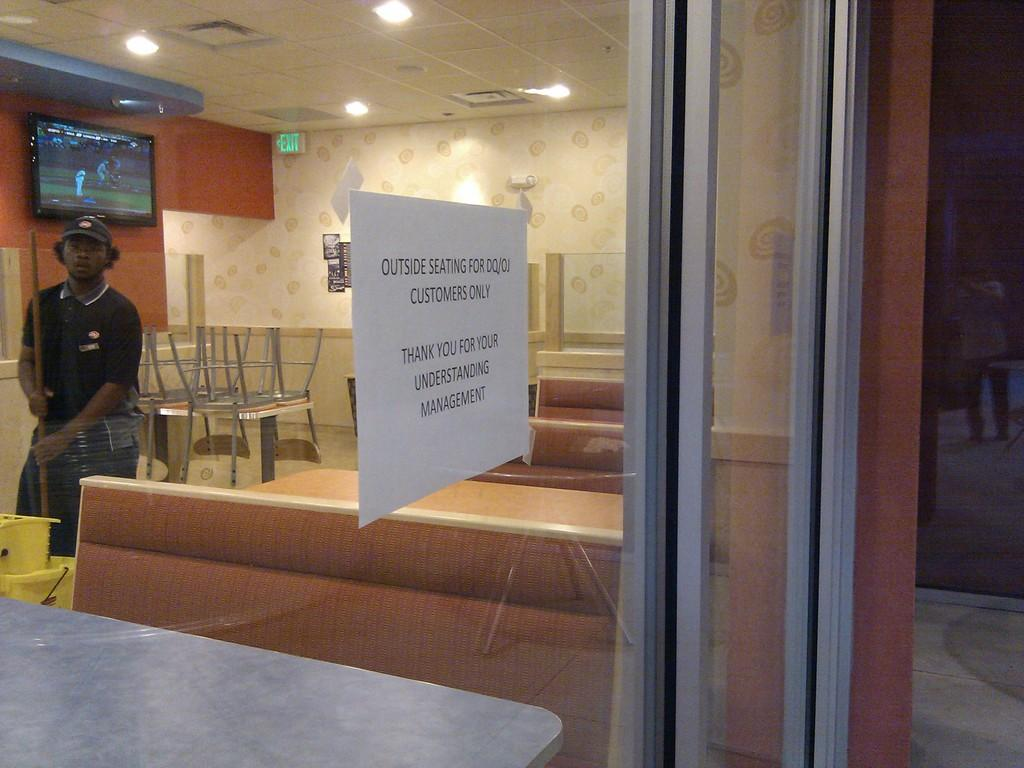What is the person in the image doing? The person is standing. What object is the person holding in the image? The person is holding a stick. What type of headwear is the person wearing? The person is wearing a cap. What can be seen in the background of the image? There is a TV, chairs, a door, and a poster in the background. What type of tin can be seen on the person's foot in the image? There is no tin visible on the person's foot in the image. How many steps are there in the image? The image does not show any steps; it only features a person, a stick, a cap, and various background elements. 